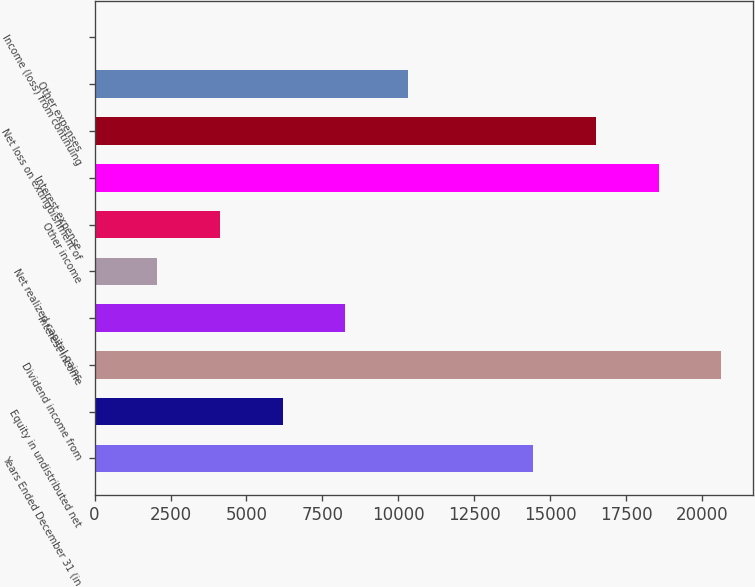Convert chart to OTSL. <chart><loc_0><loc_0><loc_500><loc_500><bar_chart><fcel>Years Ended December 31 (in<fcel>Equity in undistributed net<fcel>Dividend income from<fcel>Interest income<fcel>Net realized capital gains<fcel>Other income<fcel>Interest expense<fcel>Net loss on extinguishment of<fcel>Other expenses<fcel>Income (loss) from continuing<nl><fcel>14437.2<fcel>6190.8<fcel>20622<fcel>8252.4<fcel>2067.6<fcel>4129.2<fcel>18560.4<fcel>16498.8<fcel>10314<fcel>6<nl></chart> 